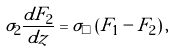<formula> <loc_0><loc_0><loc_500><loc_500>\sigma _ { 2 } \frac { d F _ { 2 } } { d z } = \sigma _ { \square } \left ( F _ { 1 } - F _ { 2 } \right ) ,</formula> 